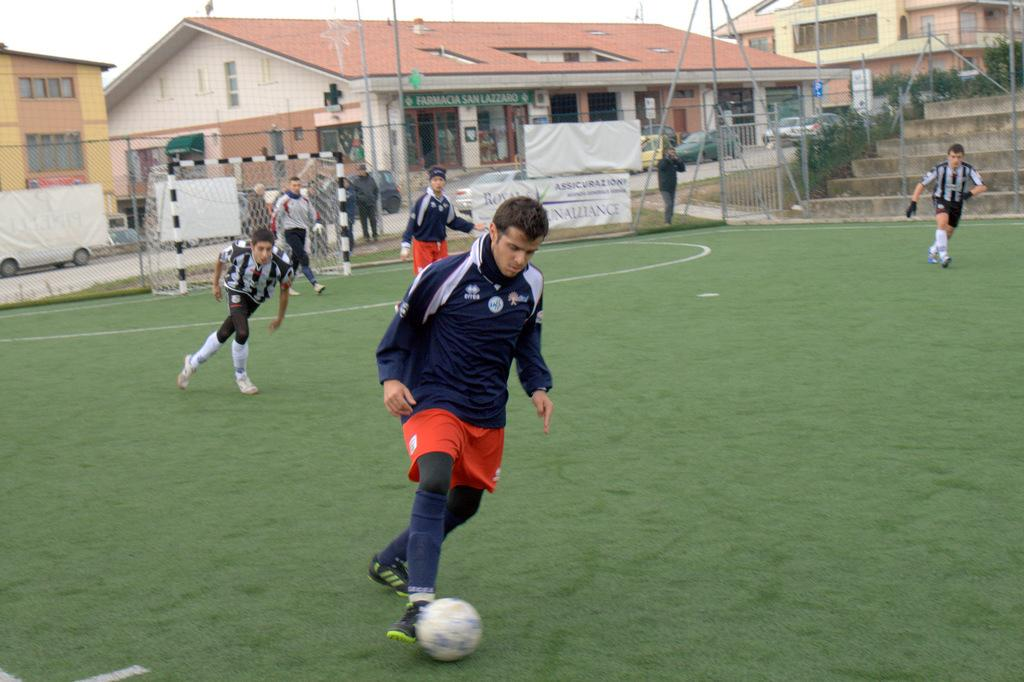What is the primary surface visible in the image? There is a ground in the image. What are the people on the ground doing? The people on the ground are playing with a football. What can be seen in the background of the image? There are buildings and more people in the background of the image. Where is the lunchroom located in the image? There is no lunchroom present in the image. Can you see any fairies flying around in the image? There are no fairies present in the image. 